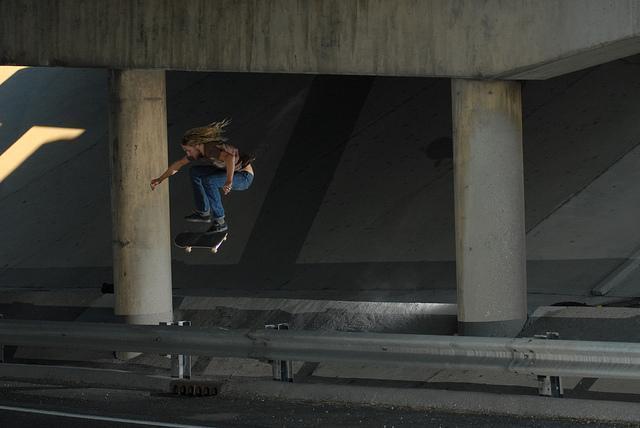How many orange slices are on the top piece of breakfast toast?
Give a very brief answer. 0. 